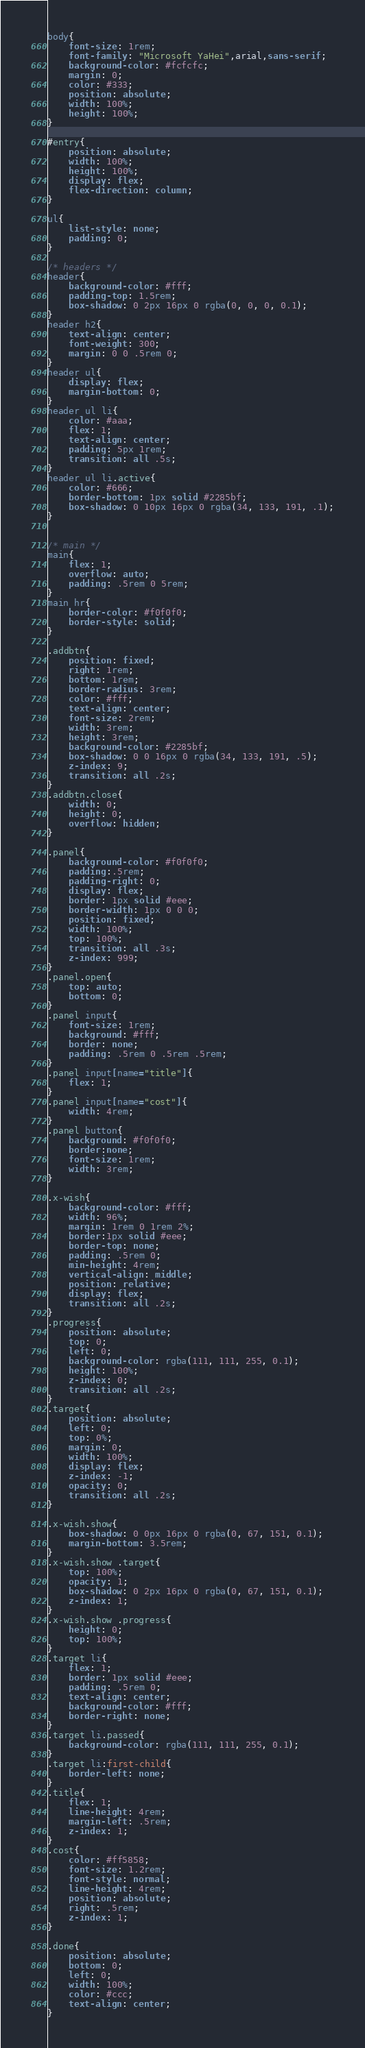Convert code to text. <code><loc_0><loc_0><loc_500><loc_500><_CSS_>body{
	font-size: 1rem;
	font-family: "Microsoft YaHei",arial,sans-serif;
	background-color: #fcfcfc;
	margin: 0;
	color: #333;
	position: absolute;
    width: 100%;
    height: 100%;
}

#entry{
	position: absolute;
    width: 100%;
    height: 100%;
    display: flex;
    flex-direction: column;
}

ul{
	list-style: none;
	padding: 0;
}

/* headers */
header{
	background-color: #fff;
	padding-top: 1.5rem;
	box-shadow: 0 2px 16px 0 rgba(0, 0, 0, 0.1);
}
header h2{
	text-align: center;
	font-weight: 300;
	margin: 0 0 .5rem 0;
}
header ul{
	display: flex;
	margin-bottom: 0;
}
header ul li{
	color: #aaa;
	flex: 1;
	text-align: center;
	padding: 5px 1rem;
	transition: all .5s;
}
header ul li.active{
	color: #666;
	border-bottom: 1px solid #2285bf;
	box-shadow: 0 10px 16px 0 rgba(34, 133, 191, .1);
}


/* main */
main{
	flex: 1;
	overflow: auto;
	padding: .5rem 0 5rem;
}
main hr{
	border-color: #f0f0f0;
    border-style: solid;
}

.addbtn{
	position: fixed;
	right: 1rem;
	bottom: 1rem;
	border-radius: 3rem;
	color: #fff;
	text-align: center;
	font-size: 2rem;
	width: 3rem;
	height: 3rem;
	background-color: #2285bf;
	box-shadow: 0 0 16px 0 rgba(34, 133, 191, .5);
	z-index: 9;
	transition: all .2s;
}
.addbtn.close{
	width: 0;
	height: 0;
	overflow: hidden;
}

.panel{
	background-color: #f0f0f0;
	padding:.5rem;
	padding-right: 0;
    display: flex;
    border: 1px solid #eee;
    border-width: 1px 0 0 0;
    position: fixed;
    width: 100%;
    top: 100%;
    transition: all .3s;
    z-index: 999;
}
.panel.open{
	top: auto;
	bottom: 0;
}
.panel input{
	font-size: 1rem;
	background: #fff;
    border: none;
    padding: .5rem 0 .5rem .5rem;
}
.panel input[name="title"]{
	flex: 1;
}
.panel input[name="cost"]{
	width: 4rem;
}
.panel button{
	background: #f0f0f0;
	border:none;
	font-size: 1rem;
	width: 3rem;
}

.x-wish{
    background-color: #fff;
    width: 96%;
    margin: 1rem 0 1rem 2%;
    border:1px solid #eee;
    border-top: none;
    padding: .5rem 0;
    min-height: 4rem;
    vertical-align: middle;
    position: relative;
    display: flex;
    transition: all .2s;
}
.progress{
    position: absolute;
    top: 0;
    left: 0;
    background-color: rgba(111, 111, 255, 0.1);
    height: 100%;
    z-index: 0;
    transition: all .2s;
}
.target{
    position: absolute;
    left: 0;
    top: 0%;
    margin: 0;
    width: 100%;
    display: flex;
    z-index: -1;
    opacity: 0;
    transition: all .2s;
}

.x-wish.show{
    box-shadow: 0 0px 16px 0 rgba(0, 67, 151, 0.1);
    margin-bottom: 3.5rem;
}
.x-wish.show .target{
    top: 100%;
    opacity: 1;
    box-shadow: 0 2px 16px 0 rgba(0, 67, 151, 0.1);
    z-index: 1;
}
.x-wish.show .progress{
    height: 0;
    top: 100%;
}
.target li{
    flex: 1;
    border: 1px solid #eee;
    padding: .5rem 0;
    text-align: center;
    background-color: #fff;
    border-right: none;
}
.target li.passed{
    background-color: rgba(111, 111, 255, 0.1);
}
.target li:first-child{
    border-left: none;
}
.title{
    flex: 1;
    line-height: 4rem;
    margin-left: .5rem;
    z-index: 1;
}
.cost{
    color: #ff5858;
    font-size: 1.2rem;
    font-style: normal;
    line-height: 4rem;
    position: absolute;
    right: .5rem;
    z-index: 1;
}

.done{
    position: absolute;
    bottom: 0;
    left: 0;
    width: 100%;
    color: #ccc;
    text-align: center;
}</code> 